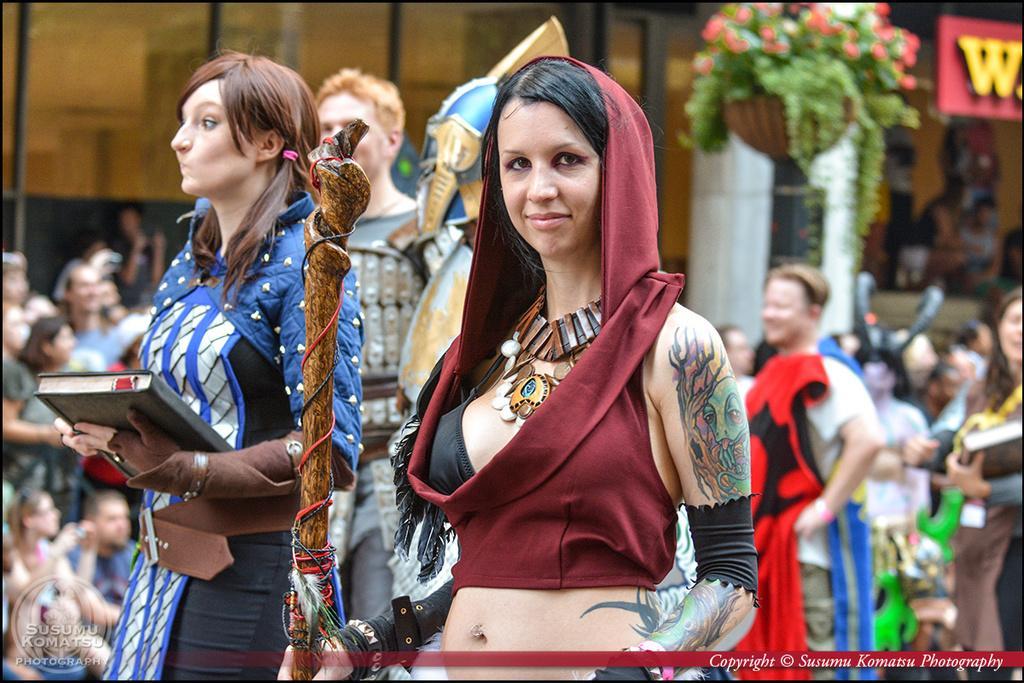Could you give a brief overview of what you see in this image? In this image we can see a few people standing and some of them are sitting, there are few objects in their hands, there is a flower pot and glass window, written text at the bottom. 